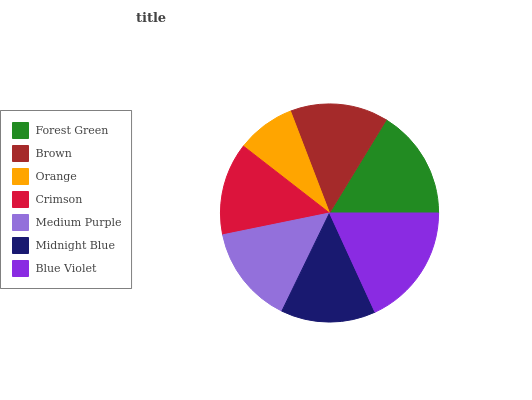Is Orange the minimum?
Answer yes or no. Yes. Is Blue Violet the maximum?
Answer yes or no. Yes. Is Brown the minimum?
Answer yes or no. No. Is Brown the maximum?
Answer yes or no. No. Is Forest Green greater than Brown?
Answer yes or no. Yes. Is Brown less than Forest Green?
Answer yes or no. Yes. Is Brown greater than Forest Green?
Answer yes or no. No. Is Forest Green less than Brown?
Answer yes or no. No. Is Brown the high median?
Answer yes or no. Yes. Is Brown the low median?
Answer yes or no. Yes. Is Medium Purple the high median?
Answer yes or no. No. Is Crimson the low median?
Answer yes or no. No. 